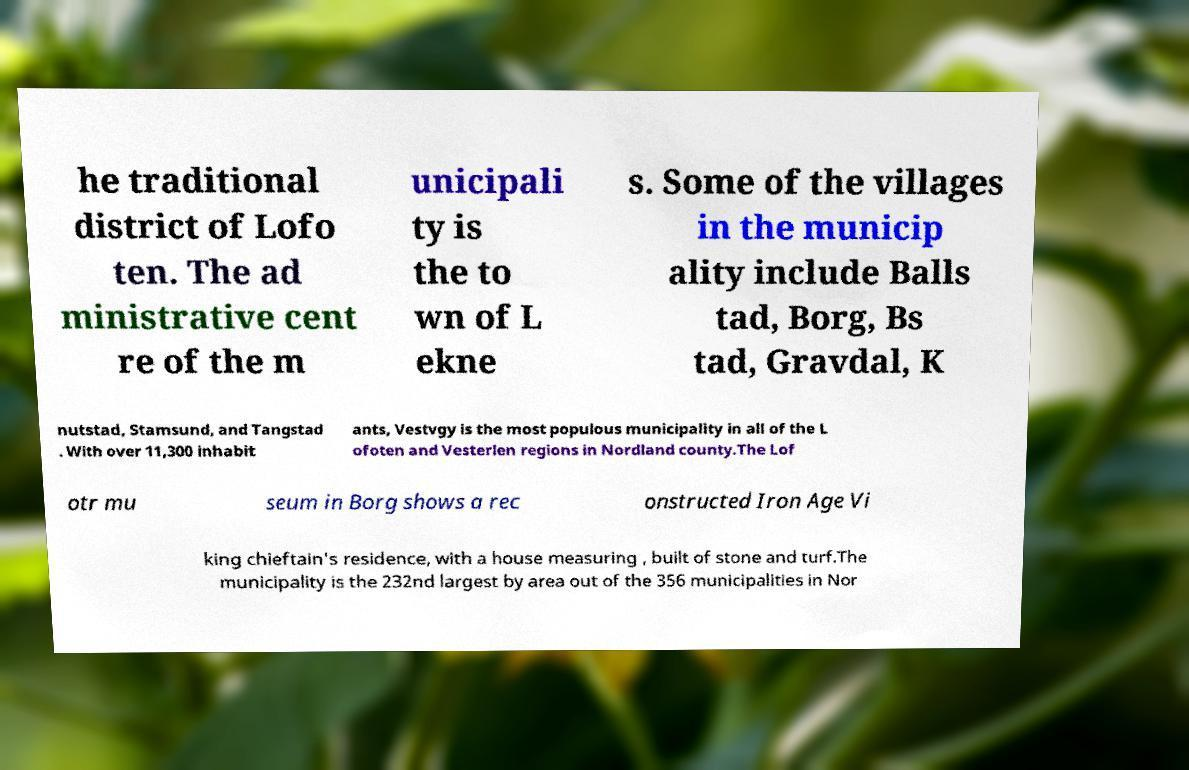Please read and relay the text visible in this image. What does it say? he traditional district of Lofo ten. The ad ministrative cent re of the m unicipali ty is the to wn of L ekne s. Some of the villages in the municip ality include Balls tad, Borg, Bs tad, Gravdal, K nutstad, Stamsund, and Tangstad . With over 11,300 inhabit ants, Vestvgy is the most populous municipality in all of the L ofoten and Vesterlen regions in Nordland county.The Lof otr mu seum in Borg shows a rec onstructed Iron Age Vi king chieftain's residence, with a house measuring , built of stone and turf.The municipality is the 232nd largest by area out of the 356 municipalities in Nor 